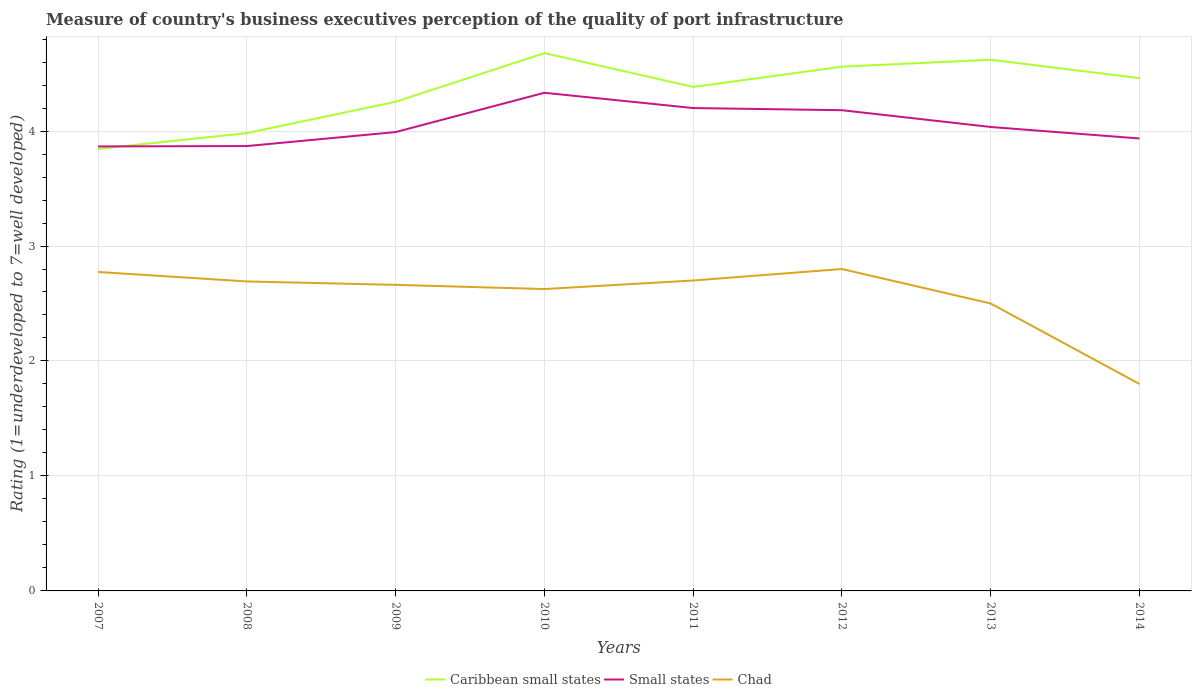How many different coloured lines are there?
Your response must be concise. 3. Does the line corresponding to Small states intersect with the line corresponding to Chad?
Offer a terse response. No. Across all years, what is the maximum ratings of the quality of port infrastructure in Chad?
Keep it short and to the point. 1.8. In which year was the ratings of the quality of port infrastructure in Caribbean small states maximum?
Your answer should be compact. 2007. What is the total ratings of the quality of port infrastructure in Small states in the graph?
Your answer should be compact. 0.13. What is the difference between the highest and the second highest ratings of the quality of port infrastructure in Caribbean small states?
Provide a short and direct response. 0.83. Is the ratings of the quality of port infrastructure in Chad strictly greater than the ratings of the quality of port infrastructure in Small states over the years?
Ensure brevity in your answer.  Yes. What is the difference between two consecutive major ticks on the Y-axis?
Your answer should be compact. 1. Does the graph contain any zero values?
Ensure brevity in your answer.  No. How are the legend labels stacked?
Keep it short and to the point. Horizontal. What is the title of the graph?
Your answer should be compact. Measure of country's business executives perception of the quality of port infrastructure. What is the label or title of the X-axis?
Offer a very short reply. Years. What is the label or title of the Y-axis?
Your answer should be very brief. Rating (1=underdeveloped to 7=well developed). What is the Rating (1=underdeveloped to 7=well developed) of Caribbean small states in 2007?
Your answer should be very brief. 3.85. What is the Rating (1=underdeveloped to 7=well developed) in Small states in 2007?
Keep it short and to the point. 3.87. What is the Rating (1=underdeveloped to 7=well developed) of Chad in 2007?
Your response must be concise. 2.77. What is the Rating (1=underdeveloped to 7=well developed) in Caribbean small states in 2008?
Offer a very short reply. 3.98. What is the Rating (1=underdeveloped to 7=well developed) in Small states in 2008?
Your answer should be compact. 3.87. What is the Rating (1=underdeveloped to 7=well developed) of Chad in 2008?
Offer a terse response. 2.69. What is the Rating (1=underdeveloped to 7=well developed) in Caribbean small states in 2009?
Your answer should be compact. 4.26. What is the Rating (1=underdeveloped to 7=well developed) in Small states in 2009?
Offer a terse response. 3.99. What is the Rating (1=underdeveloped to 7=well developed) in Chad in 2009?
Your answer should be compact. 2.66. What is the Rating (1=underdeveloped to 7=well developed) in Caribbean small states in 2010?
Make the answer very short. 4.68. What is the Rating (1=underdeveloped to 7=well developed) of Small states in 2010?
Offer a very short reply. 4.33. What is the Rating (1=underdeveloped to 7=well developed) in Chad in 2010?
Offer a terse response. 2.63. What is the Rating (1=underdeveloped to 7=well developed) of Caribbean small states in 2011?
Offer a very short reply. 4.38. What is the Rating (1=underdeveloped to 7=well developed) in Small states in 2011?
Provide a succinct answer. 4.2. What is the Rating (1=underdeveloped to 7=well developed) of Chad in 2011?
Make the answer very short. 2.7. What is the Rating (1=underdeveloped to 7=well developed) in Caribbean small states in 2012?
Make the answer very short. 4.56. What is the Rating (1=underdeveloped to 7=well developed) of Small states in 2012?
Provide a succinct answer. 4.18. What is the Rating (1=underdeveloped to 7=well developed) in Chad in 2012?
Your response must be concise. 2.8. What is the Rating (1=underdeveloped to 7=well developed) in Caribbean small states in 2013?
Your response must be concise. 4.62. What is the Rating (1=underdeveloped to 7=well developed) in Small states in 2013?
Give a very brief answer. 4.04. What is the Rating (1=underdeveloped to 7=well developed) of Caribbean small states in 2014?
Your answer should be very brief. 4.46. What is the Rating (1=underdeveloped to 7=well developed) in Small states in 2014?
Your response must be concise. 3.94. Across all years, what is the maximum Rating (1=underdeveloped to 7=well developed) of Caribbean small states?
Offer a terse response. 4.68. Across all years, what is the maximum Rating (1=underdeveloped to 7=well developed) of Small states?
Give a very brief answer. 4.33. Across all years, what is the minimum Rating (1=underdeveloped to 7=well developed) in Caribbean small states?
Ensure brevity in your answer.  3.85. Across all years, what is the minimum Rating (1=underdeveloped to 7=well developed) of Small states?
Your response must be concise. 3.87. Across all years, what is the minimum Rating (1=underdeveloped to 7=well developed) of Chad?
Your response must be concise. 1.8. What is the total Rating (1=underdeveloped to 7=well developed) in Caribbean small states in the graph?
Provide a succinct answer. 34.78. What is the total Rating (1=underdeveloped to 7=well developed) in Small states in the graph?
Give a very brief answer. 32.41. What is the total Rating (1=underdeveloped to 7=well developed) of Chad in the graph?
Keep it short and to the point. 20.55. What is the difference between the Rating (1=underdeveloped to 7=well developed) in Caribbean small states in 2007 and that in 2008?
Provide a succinct answer. -0.14. What is the difference between the Rating (1=underdeveloped to 7=well developed) of Small states in 2007 and that in 2008?
Your answer should be very brief. -0. What is the difference between the Rating (1=underdeveloped to 7=well developed) in Chad in 2007 and that in 2008?
Provide a succinct answer. 0.08. What is the difference between the Rating (1=underdeveloped to 7=well developed) in Caribbean small states in 2007 and that in 2009?
Make the answer very short. -0.41. What is the difference between the Rating (1=underdeveloped to 7=well developed) of Small states in 2007 and that in 2009?
Provide a short and direct response. -0.12. What is the difference between the Rating (1=underdeveloped to 7=well developed) of Chad in 2007 and that in 2009?
Offer a terse response. 0.11. What is the difference between the Rating (1=underdeveloped to 7=well developed) in Caribbean small states in 2007 and that in 2010?
Keep it short and to the point. -0.83. What is the difference between the Rating (1=underdeveloped to 7=well developed) of Small states in 2007 and that in 2010?
Your answer should be compact. -0.47. What is the difference between the Rating (1=underdeveloped to 7=well developed) in Chad in 2007 and that in 2010?
Ensure brevity in your answer.  0.15. What is the difference between the Rating (1=underdeveloped to 7=well developed) of Caribbean small states in 2007 and that in 2011?
Offer a very short reply. -0.54. What is the difference between the Rating (1=underdeveloped to 7=well developed) in Small states in 2007 and that in 2011?
Offer a terse response. -0.33. What is the difference between the Rating (1=underdeveloped to 7=well developed) in Chad in 2007 and that in 2011?
Your answer should be compact. 0.07. What is the difference between the Rating (1=underdeveloped to 7=well developed) of Caribbean small states in 2007 and that in 2012?
Give a very brief answer. -0.71. What is the difference between the Rating (1=underdeveloped to 7=well developed) of Small states in 2007 and that in 2012?
Offer a very short reply. -0.32. What is the difference between the Rating (1=underdeveloped to 7=well developed) in Chad in 2007 and that in 2012?
Give a very brief answer. -0.03. What is the difference between the Rating (1=underdeveloped to 7=well developed) of Caribbean small states in 2007 and that in 2013?
Your response must be concise. -0.77. What is the difference between the Rating (1=underdeveloped to 7=well developed) of Small states in 2007 and that in 2013?
Make the answer very short. -0.17. What is the difference between the Rating (1=underdeveloped to 7=well developed) of Chad in 2007 and that in 2013?
Make the answer very short. 0.27. What is the difference between the Rating (1=underdeveloped to 7=well developed) in Caribbean small states in 2007 and that in 2014?
Your answer should be very brief. -0.61. What is the difference between the Rating (1=underdeveloped to 7=well developed) of Small states in 2007 and that in 2014?
Make the answer very short. -0.07. What is the difference between the Rating (1=underdeveloped to 7=well developed) in Chad in 2007 and that in 2014?
Give a very brief answer. 0.97. What is the difference between the Rating (1=underdeveloped to 7=well developed) in Caribbean small states in 2008 and that in 2009?
Keep it short and to the point. -0.27. What is the difference between the Rating (1=underdeveloped to 7=well developed) in Small states in 2008 and that in 2009?
Your response must be concise. -0.12. What is the difference between the Rating (1=underdeveloped to 7=well developed) in Chad in 2008 and that in 2009?
Make the answer very short. 0.03. What is the difference between the Rating (1=underdeveloped to 7=well developed) in Caribbean small states in 2008 and that in 2010?
Keep it short and to the point. -0.7. What is the difference between the Rating (1=underdeveloped to 7=well developed) of Small states in 2008 and that in 2010?
Offer a terse response. -0.46. What is the difference between the Rating (1=underdeveloped to 7=well developed) in Chad in 2008 and that in 2010?
Provide a succinct answer. 0.07. What is the difference between the Rating (1=underdeveloped to 7=well developed) in Caribbean small states in 2008 and that in 2011?
Your answer should be very brief. -0.4. What is the difference between the Rating (1=underdeveloped to 7=well developed) in Small states in 2008 and that in 2011?
Your response must be concise. -0.33. What is the difference between the Rating (1=underdeveloped to 7=well developed) of Chad in 2008 and that in 2011?
Offer a very short reply. -0.01. What is the difference between the Rating (1=underdeveloped to 7=well developed) of Caribbean small states in 2008 and that in 2012?
Keep it short and to the point. -0.58. What is the difference between the Rating (1=underdeveloped to 7=well developed) in Small states in 2008 and that in 2012?
Offer a terse response. -0.31. What is the difference between the Rating (1=underdeveloped to 7=well developed) of Chad in 2008 and that in 2012?
Offer a very short reply. -0.11. What is the difference between the Rating (1=underdeveloped to 7=well developed) in Caribbean small states in 2008 and that in 2013?
Your answer should be compact. -0.64. What is the difference between the Rating (1=underdeveloped to 7=well developed) of Small states in 2008 and that in 2013?
Keep it short and to the point. -0.17. What is the difference between the Rating (1=underdeveloped to 7=well developed) of Chad in 2008 and that in 2013?
Ensure brevity in your answer.  0.19. What is the difference between the Rating (1=underdeveloped to 7=well developed) in Caribbean small states in 2008 and that in 2014?
Make the answer very short. -0.48. What is the difference between the Rating (1=underdeveloped to 7=well developed) of Small states in 2008 and that in 2014?
Keep it short and to the point. -0.07. What is the difference between the Rating (1=underdeveloped to 7=well developed) of Chad in 2008 and that in 2014?
Your response must be concise. 0.89. What is the difference between the Rating (1=underdeveloped to 7=well developed) in Caribbean small states in 2009 and that in 2010?
Offer a very short reply. -0.42. What is the difference between the Rating (1=underdeveloped to 7=well developed) in Small states in 2009 and that in 2010?
Make the answer very short. -0.34. What is the difference between the Rating (1=underdeveloped to 7=well developed) of Chad in 2009 and that in 2010?
Keep it short and to the point. 0.04. What is the difference between the Rating (1=underdeveloped to 7=well developed) in Caribbean small states in 2009 and that in 2011?
Keep it short and to the point. -0.13. What is the difference between the Rating (1=underdeveloped to 7=well developed) in Small states in 2009 and that in 2011?
Make the answer very short. -0.21. What is the difference between the Rating (1=underdeveloped to 7=well developed) in Chad in 2009 and that in 2011?
Keep it short and to the point. -0.04. What is the difference between the Rating (1=underdeveloped to 7=well developed) in Caribbean small states in 2009 and that in 2012?
Your response must be concise. -0.3. What is the difference between the Rating (1=underdeveloped to 7=well developed) of Small states in 2009 and that in 2012?
Your answer should be very brief. -0.19. What is the difference between the Rating (1=underdeveloped to 7=well developed) of Chad in 2009 and that in 2012?
Keep it short and to the point. -0.14. What is the difference between the Rating (1=underdeveloped to 7=well developed) in Caribbean small states in 2009 and that in 2013?
Provide a short and direct response. -0.36. What is the difference between the Rating (1=underdeveloped to 7=well developed) of Small states in 2009 and that in 2013?
Keep it short and to the point. -0.04. What is the difference between the Rating (1=underdeveloped to 7=well developed) in Chad in 2009 and that in 2013?
Your response must be concise. 0.16. What is the difference between the Rating (1=underdeveloped to 7=well developed) of Caribbean small states in 2009 and that in 2014?
Your answer should be compact. -0.2. What is the difference between the Rating (1=underdeveloped to 7=well developed) of Small states in 2009 and that in 2014?
Make the answer very short. 0.06. What is the difference between the Rating (1=underdeveloped to 7=well developed) in Chad in 2009 and that in 2014?
Your answer should be compact. 0.86. What is the difference between the Rating (1=underdeveloped to 7=well developed) in Caribbean small states in 2010 and that in 2011?
Your answer should be very brief. 0.29. What is the difference between the Rating (1=underdeveloped to 7=well developed) of Small states in 2010 and that in 2011?
Offer a terse response. 0.13. What is the difference between the Rating (1=underdeveloped to 7=well developed) of Chad in 2010 and that in 2011?
Your answer should be compact. -0.07. What is the difference between the Rating (1=underdeveloped to 7=well developed) of Caribbean small states in 2010 and that in 2012?
Your response must be concise. 0.12. What is the difference between the Rating (1=underdeveloped to 7=well developed) of Small states in 2010 and that in 2012?
Keep it short and to the point. 0.15. What is the difference between the Rating (1=underdeveloped to 7=well developed) of Chad in 2010 and that in 2012?
Your answer should be compact. -0.17. What is the difference between the Rating (1=underdeveloped to 7=well developed) of Caribbean small states in 2010 and that in 2013?
Your answer should be compact. 0.06. What is the difference between the Rating (1=underdeveloped to 7=well developed) of Small states in 2010 and that in 2013?
Keep it short and to the point. 0.3. What is the difference between the Rating (1=underdeveloped to 7=well developed) of Chad in 2010 and that in 2013?
Provide a short and direct response. 0.13. What is the difference between the Rating (1=underdeveloped to 7=well developed) of Caribbean small states in 2010 and that in 2014?
Offer a terse response. 0.22. What is the difference between the Rating (1=underdeveloped to 7=well developed) in Small states in 2010 and that in 2014?
Make the answer very short. 0.4. What is the difference between the Rating (1=underdeveloped to 7=well developed) in Chad in 2010 and that in 2014?
Offer a very short reply. 0.83. What is the difference between the Rating (1=underdeveloped to 7=well developed) in Caribbean small states in 2011 and that in 2012?
Make the answer very short. -0.18. What is the difference between the Rating (1=underdeveloped to 7=well developed) in Small states in 2011 and that in 2012?
Your answer should be very brief. 0.02. What is the difference between the Rating (1=underdeveloped to 7=well developed) in Caribbean small states in 2011 and that in 2013?
Give a very brief answer. -0.24. What is the difference between the Rating (1=underdeveloped to 7=well developed) of Small states in 2011 and that in 2013?
Make the answer very short. 0.16. What is the difference between the Rating (1=underdeveloped to 7=well developed) in Caribbean small states in 2011 and that in 2014?
Give a very brief answer. -0.08. What is the difference between the Rating (1=underdeveloped to 7=well developed) in Small states in 2011 and that in 2014?
Offer a very short reply. 0.26. What is the difference between the Rating (1=underdeveloped to 7=well developed) of Chad in 2011 and that in 2014?
Give a very brief answer. 0.9. What is the difference between the Rating (1=underdeveloped to 7=well developed) in Caribbean small states in 2012 and that in 2013?
Keep it short and to the point. -0.06. What is the difference between the Rating (1=underdeveloped to 7=well developed) of Small states in 2012 and that in 2013?
Provide a short and direct response. 0.15. What is the difference between the Rating (1=underdeveloped to 7=well developed) in Small states in 2012 and that in 2014?
Provide a short and direct response. 0.25. What is the difference between the Rating (1=underdeveloped to 7=well developed) in Chad in 2012 and that in 2014?
Ensure brevity in your answer.  1. What is the difference between the Rating (1=underdeveloped to 7=well developed) in Caribbean small states in 2013 and that in 2014?
Your response must be concise. 0.16. What is the difference between the Rating (1=underdeveloped to 7=well developed) in Caribbean small states in 2007 and the Rating (1=underdeveloped to 7=well developed) in Small states in 2008?
Provide a short and direct response. -0.02. What is the difference between the Rating (1=underdeveloped to 7=well developed) in Caribbean small states in 2007 and the Rating (1=underdeveloped to 7=well developed) in Chad in 2008?
Provide a succinct answer. 1.15. What is the difference between the Rating (1=underdeveloped to 7=well developed) of Small states in 2007 and the Rating (1=underdeveloped to 7=well developed) of Chad in 2008?
Make the answer very short. 1.17. What is the difference between the Rating (1=underdeveloped to 7=well developed) of Caribbean small states in 2007 and the Rating (1=underdeveloped to 7=well developed) of Small states in 2009?
Your response must be concise. -0.15. What is the difference between the Rating (1=underdeveloped to 7=well developed) in Caribbean small states in 2007 and the Rating (1=underdeveloped to 7=well developed) in Chad in 2009?
Your answer should be very brief. 1.18. What is the difference between the Rating (1=underdeveloped to 7=well developed) in Small states in 2007 and the Rating (1=underdeveloped to 7=well developed) in Chad in 2009?
Ensure brevity in your answer.  1.2. What is the difference between the Rating (1=underdeveloped to 7=well developed) of Caribbean small states in 2007 and the Rating (1=underdeveloped to 7=well developed) of Small states in 2010?
Provide a succinct answer. -0.49. What is the difference between the Rating (1=underdeveloped to 7=well developed) in Caribbean small states in 2007 and the Rating (1=underdeveloped to 7=well developed) in Chad in 2010?
Your answer should be very brief. 1.22. What is the difference between the Rating (1=underdeveloped to 7=well developed) in Small states in 2007 and the Rating (1=underdeveloped to 7=well developed) in Chad in 2010?
Your response must be concise. 1.24. What is the difference between the Rating (1=underdeveloped to 7=well developed) in Caribbean small states in 2007 and the Rating (1=underdeveloped to 7=well developed) in Small states in 2011?
Make the answer very short. -0.35. What is the difference between the Rating (1=underdeveloped to 7=well developed) in Caribbean small states in 2007 and the Rating (1=underdeveloped to 7=well developed) in Chad in 2011?
Provide a succinct answer. 1.15. What is the difference between the Rating (1=underdeveloped to 7=well developed) of Small states in 2007 and the Rating (1=underdeveloped to 7=well developed) of Chad in 2011?
Offer a very short reply. 1.17. What is the difference between the Rating (1=underdeveloped to 7=well developed) of Caribbean small states in 2007 and the Rating (1=underdeveloped to 7=well developed) of Small states in 2012?
Provide a short and direct response. -0.34. What is the difference between the Rating (1=underdeveloped to 7=well developed) in Caribbean small states in 2007 and the Rating (1=underdeveloped to 7=well developed) in Chad in 2012?
Make the answer very short. 1.05. What is the difference between the Rating (1=underdeveloped to 7=well developed) in Small states in 2007 and the Rating (1=underdeveloped to 7=well developed) in Chad in 2012?
Ensure brevity in your answer.  1.07. What is the difference between the Rating (1=underdeveloped to 7=well developed) in Caribbean small states in 2007 and the Rating (1=underdeveloped to 7=well developed) in Small states in 2013?
Offer a terse response. -0.19. What is the difference between the Rating (1=underdeveloped to 7=well developed) of Caribbean small states in 2007 and the Rating (1=underdeveloped to 7=well developed) of Chad in 2013?
Your answer should be compact. 1.35. What is the difference between the Rating (1=underdeveloped to 7=well developed) of Small states in 2007 and the Rating (1=underdeveloped to 7=well developed) of Chad in 2013?
Offer a very short reply. 1.37. What is the difference between the Rating (1=underdeveloped to 7=well developed) in Caribbean small states in 2007 and the Rating (1=underdeveloped to 7=well developed) in Small states in 2014?
Offer a terse response. -0.09. What is the difference between the Rating (1=underdeveloped to 7=well developed) in Caribbean small states in 2007 and the Rating (1=underdeveloped to 7=well developed) in Chad in 2014?
Offer a very short reply. 2.05. What is the difference between the Rating (1=underdeveloped to 7=well developed) of Small states in 2007 and the Rating (1=underdeveloped to 7=well developed) of Chad in 2014?
Offer a terse response. 2.07. What is the difference between the Rating (1=underdeveloped to 7=well developed) of Caribbean small states in 2008 and the Rating (1=underdeveloped to 7=well developed) of Small states in 2009?
Provide a short and direct response. -0.01. What is the difference between the Rating (1=underdeveloped to 7=well developed) of Caribbean small states in 2008 and the Rating (1=underdeveloped to 7=well developed) of Chad in 2009?
Your answer should be very brief. 1.32. What is the difference between the Rating (1=underdeveloped to 7=well developed) of Small states in 2008 and the Rating (1=underdeveloped to 7=well developed) of Chad in 2009?
Your answer should be very brief. 1.21. What is the difference between the Rating (1=underdeveloped to 7=well developed) of Caribbean small states in 2008 and the Rating (1=underdeveloped to 7=well developed) of Small states in 2010?
Make the answer very short. -0.35. What is the difference between the Rating (1=underdeveloped to 7=well developed) of Caribbean small states in 2008 and the Rating (1=underdeveloped to 7=well developed) of Chad in 2010?
Your response must be concise. 1.36. What is the difference between the Rating (1=underdeveloped to 7=well developed) of Small states in 2008 and the Rating (1=underdeveloped to 7=well developed) of Chad in 2010?
Your answer should be very brief. 1.24. What is the difference between the Rating (1=underdeveloped to 7=well developed) of Caribbean small states in 2008 and the Rating (1=underdeveloped to 7=well developed) of Small states in 2011?
Keep it short and to the point. -0.22. What is the difference between the Rating (1=underdeveloped to 7=well developed) of Caribbean small states in 2008 and the Rating (1=underdeveloped to 7=well developed) of Chad in 2011?
Keep it short and to the point. 1.28. What is the difference between the Rating (1=underdeveloped to 7=well developed) of Small states in 2008 and the Rating (1=underdeveloped to 7=well developed) of Chad in 2011?
Make the answer very short. 1.17. What is the difference between the Rating (1=underdeveloped to 7=well developed) in Caribbean small states in 2008 and the Rating (1=underdeveloped to 7=well developed) in Small states in 2012?
Offer a very short reply. -0.2. What is the difference between the Rating (1=underdeveloped to 7=well developed) of Caribbean small states in 2008 and the Rating (1=underdeveloped to 7=well developed) of Chad in 2012?
Keep it short and to the point. 1.18. What is the difference between the Rating (1=underdeveloped to 7=well developed) of Small states in 2008 and the Rating (1=underdeveloped to 7=well developed) of Chad in 2012?
Keep it short and to the point. 1.07. What is the difference between the Rating (1=underdeveloped to 7=well developed) of Caribbean small states in 2008 and the Rating (1=underdeveloped to 7=well developed) of Small states in 2013?
Your answer should be very brief. -0.05. What is the difference between the Rating (1=underdeveloped to 7=well developed) of Caribbean small states in 2008 and the Rating (1=underdeveloped to 7=well developed) of Chad in 2013?
Offer a very short reply. 1.48. What is the difference between the Rating (1=underdeveloped to 7=well developed) in Small states in 2008 and the Rating (1=underdeveloped to 7=well developed) in Chad in 2013?
Your answer should be very brief. 1.37. What is the difference between the Rating (1=underdeveloped to 7=well developed) of Caribbean small states in 2008 and the Rating (1=underdeveloped to 7=well developed) of Small states in 2014?
Your answer should be very brief. 0.05. What is the difference between the Rating (1=underdeveloped to 7=well developed) in Caribbean small states in 2008 and the Rating (1=underdeveloped to 7=well developed) in Chad in 2014?
Your response must be concise. 2.18. What is the difference between the Rating (1=underdeveloped to 7=well developed) in Small states in 2008 and the Rating (1=underdeveloped to 7=well developed) in Chad in 2014?
Offer a very short reply. 2.07. What is the difference between the Rating (1=underdeveloped to 7=well developed) in Caribbean small states in 2009 and the Rating (1=underdeveloped to 7=well developed) in Small states in 2010?
Offer a very short reply. -0.08. What is the difference between the Rating (1=underdeveloped to 7=well developed) of Caribbean small states in 2009 and the Rating (1=underdeveloped to 7=well developed) of Chad in 2010?
Your answer should be compact. 1.63. What is the difference between the Rating (1=underdeveloped to 7=well developed) of Small states in 2009 and the Rating (1=underdeveloped to 7=well developed) of Chad in 2010?
Provide a succinct answer. 1.37. What is the difference between the Rating (1=underdeveloped to 7=well developed) of Caribbean small states in 2009 and the Rating (1=underdeveloped to 7=well developed) of Small states in 2011?
Keep it short and to the point. 0.06. What is the difference between the Rating (1=underdeveloped to 7=well developed) of Caribbean small states in 2009 and the Rating (1=underdeveloped to 7=well developed) of Chad in 2011?
Give a very brief answer. 1.56. What is the difference between the Rating (1=underdeveloped to 7=well developed) of Small states in 2009 and the Rating (1=underdeveloped to 7=well developed) of Chad in 2011?
Your response must be concise. 1.29. What is the difference between the Rating (1=underdeveloped to 7=well developed) in Caribbean small states in 2009 and the Rating (1=underdeveloped to 7=well developed) in Small states in 2012?
Keep it short and to the point. 0.07. What is the difference between the Rating (1=underdeveloped to 7=well developed) of Caribbean small states in 2009 and the Rating (1=underdeveloped to 7=well developed) of Chad in 2012?
Your answer should be very brief. 1.46. What is the difference between the Rating (1=underdeveloped to 7=well developed) in Small states in 2009 and the Rating (1=underdeveloped to 7=well developed) in Chad in 2012?
Make the answer very short. 1.19. What is the difference between the Rating (1=underdeveloped to 7=well developed) of Caribbean small states in 2009 and the Rating (1=underdeveloped to 7=well developed) of Small states in 2013?
Keep it short and to the point. 0.22. What is the difference between the Rating (1=underdeveloped to 7=well developed) in Caribbean small states in 2009 and the Rating (1=underdeveloped to 7=well developed) in Chad in 2013?
Your answer should be very brief. 1.76. What is the difference between the Rating (1=underdeveloped to 7=well developed) in Small states in 2009 and the Rating (1=underdeveloped to 7=well developed) in Chad in 2013?
Ensure brevity in your answer.  1.49. What is the difference between the Rating (1=underdeveloped to 7=well developed) of Caribbean small states in 2009 and the Rating (1=underdeveloped to 7=well developed) of Small states in 2014?
Keep it short and to the point. 0.32. What is the difference between the Rating (1=underdeveloped to 7=well developed) of Caribbean small states in 2009 and the Rating (1=underdeveloped to 7=well developed) of Chad in 2014?
Ensure brevity in your answer.  2.46. What is the difference between the Rating (1=underdeveloped to 7=well developed) of Small states in 2009 and the Rating (1=underdeveloped to 7=well developed) of Chad in 2014?
Your response must be concise. 2.19. What is the difference between the Rating (1=underdeveloped to 7=well developed) in Caribbean small states in 2010 and the Rating (1=underdeveloped to 7=well developed) in Small states in 2011?
Make the answer very short. 0.48. What is the difference between the Rating (1=underdeveloped to 7=well developed) in Caribbean small states in 2010 and the Rating (1=underdeveloped to 7=well developed) in Chad in 2011?
Make the answer very short. 1.98. What is the difference between the Rating (1=underdeveloped to 7=well developed) of Small states in 2010 and the Rating (1=underdeveloped to 7=well developed) of Chad in 2011?
Your answer should be very brief. 1.63. What is the difference between the Rating (1=underdeveloped to 7=well developed) of Caribbean small states in 2010 and the Rating (1=underdeveloped to 7=well developed) of Small states in 2012?
Your answer should be compact. 0.5. What is the difference between the Rating (1=underdeveloped to 7=well developed) of Caribbean small states in 2010 and the Rating (1=underdeveloped to 7=well developed) of Chad in 2012?
Your answer should be very brief. 1.88. What is the difference between the Rating (1=underdeveloped to 7=well developed) of Small states in 2010 and the Rating (1=underdeveloped to 7=well developed) of Chad in 2012?
Your answer should be compact. 1.53. What is the difference between the Rating (1=underdeveloped to 7=well developed) in Caribbean small states in 2010 and the Rating (1=underdeveloped to 7=well developed) in Small states in 2013?
Provide a short and direct response. 0.64. What is the difference between the Rating (1=underdeveloped to 7=well developed) of Caribbean small states in 2010 and the Rating (1=underdeveloped to 7=well developed) of Chad in 2013?
Offer a terse response. 2.18. What is the difference between the Rating (1=underdeveloped to 7=well developed) of Small states in 2010 and the Rating (1=underdeveloped to 7=well developed) of Chad in 2013?
Your response must be concise. 1.83. What is the difference between the Rating (1=underdeveloped to 7=well developed) in Caribbean small states in 2010 and the Rating (1=underdeveloped to 7=well developed) in Small states in 2014?
Ensure brevity in your answer.  0.74. What is the difference between the Rating (1=underdeveloped to 7=well developed) in Caribbean small states in 2010 and the Rating (1=underdeveloped to 7=well developed) in Chad in 2014?
Give a very brief answer. 2.88. What is the difference between the Rating (1=underdeveloped to 7=well developed) of Small states in 2010 and the Rating (1=underdeveloped to 7=well developed) of Chad in 2014?
Offer a very short reply. 2.53. What is the difference between the Rating (1=underdeveloped to 7=well developed) of Caribbean small states in 2011 and the Rating (1=underdeveloped to 7=well developed) of Small states in 2012?
Ensure brevity in your answer.  0.2. What is the difference between the Rating (1=underdeveloped to 7=well developed) in Caribbean small states in 2011 and the Rating (1=underdeveloped to 7=well developed) in Chad in 2012?
Offer a terse response. 1.58. What is the difference between the Rating (1=underdeveloped to 7=well developed) in Small states in 2011 and the Rating (1=underdeveloped to 7=well developed) in Chad in 2012?
Your response must be concise. 1.4. What is the difference between the Rating (1=underdeveloped to 7=well developed) in Caribbean small states in 2011 and the Rating (1=underdeveloped to 7=well developed) in Small states in 2013?
Your response must be concise. 0.35. What is the difference between the Rating (1=underdeveloped to 7=well developed) of Caribbean small states in 2011 and the Rating (1=underdeveloped to 7=well developed) of Chad in 2013?
Keep it short and to the point. 1.88. What is the difference between the Rating (1=underdeveloped to 7=well developed) in Caribbean small states in 2011 and the Rating (1=underdeveloped to 7=well developed) in Small states in 2014?
Your answer should be compact. 0.45. What is the difference between the Rating (1=underdeveloped to 7=well developed) of Caribbean small states in 2011 and the Rating (1=underdeveloped to 7=well developed) of Chad in 2014?
Provide a succinct answer. 2.58. What is the difference between the Rating (1=underdeveloped to 7=well developed) of Caribbean small states in 2012 and the Rating (1=underdeveloped to 7=well developed) of Small states in 2013?
Provide a short and direct response. 0.52. What is the difference between the Rating (1=underdeveloped to 7=well developed) of Caribbean small states in 2012 and the Rating (1=underdeveloped to 7=well developed) of Chad in 2013?
Keep it short and to the point. 2.06. What is the difference between the Rating (1=underdeveloped to 7=well developed) of Small states in 2012 and the Rating (1=underdeveloped to 7=well developed) of Chad in 2013?
Keep it short and to the point. 1.68. What is the difference between the Rating (1=underdeveloped to 7=well developed) in Caribbean small states in 2012 and the Rating (1=underdeveloped to 7=well developed) in Small states in 2014?
Give a very brief answer. 0.62. What is the difference between the Rating (1=underdeveloped to 7=well developed) in Caribbean small states in 2012 and the Rating (1=underdeveloped to 7=well developed) in Chad in 2014?
Your answer should be very brief. 2.76. What is the difference between the Rating (1=underdeveloped to 7=well developed) of Small states in 2012 and the Rating (1=underdeveloped to 7=well developed) of Chad in 2014?
Your answer should be very brief. 2.38. What is the difference between the Rating (1=underdeveloped to 7=well developed) in Caribbean small states in 2013 and the Rating (1=underdeveloped to 7=well developed) in Small states in 2014?
Offer a very short reply. 0.68. What is the difference between the Rating (1=underdeveloped to 7=well developed) in Caribbean small states in 2013 and the Rating (1=underdeveloped to 7=well developed) in Chad in 2014?
Your answer should be very brief. 2.82. What is the difference between the Rating (1=underdeveloped to 7=well developed) in Small states in 2013 and the Rating (1=underdeveloped to 7=well developed) in Chad in 2014?
Offer a very short reply. 2.24. What is the average Rating (1=underdeveloped to 7=well developed) in Caribbean small states per year?
Make the answer very short. 4.35. What is the average Rating (1=underdeveloped to 7=well developed) in Small states per year?
Provide a short and direct response. 4.05. What is the average Rating (1=underdeveloped to 7=well developed) in Chad per year?
Your answer should be compact. 2.57. In the year 2007, what is the difference between the Rating (1=underdeveloped to 7=well developed) of Caribbean small states and Rating (1=underdeveloped to 7=well developed) of Small states?
Make the answer very short. -0.02. In the year 2007, what is the difference between the Rating (1=underdeveloped to 7=well developed) in Caribbean small states and Rating (1=underdeveloped to 7=well developed) in Chad?
Offer a terse response. 1.07. In the year 2007, what is the difference between the Rating (1=underdeveloped to 7=well developed) of Small states and Rating (1=underdeveloped to 7=well developed) of Chad?
Offer a very short reply. 1.09. In the year 2008, what is the difference between the Rating (1=underdeveloped to 7=well developed) in Caribbean small states and Rating (1=underdeveloped to 7=well developed) in Small states?
Ensure brevity in your answer.  0.11. In the year 2008, what is the difference between the Rating (1=underdeveloped to 7=well developed) in Caribbean small states and Rating (1=underdeveloped to 7=well developed) in Chad?
Offer a very short reply. 1.29. In the year 2008, what is the difference between the Rating (1=underdeveloped to 7=well developed) of Small states and Rating (1=underdeveloped to 7=well developed) of Chad?
Ensure brevity in your answer.  1.18. In the year 2009, what is the difference between the Rating (1=underdeveloped to 7=well developed) of Caribbean small states and Rating (1=underdeveloped to 7=well developed) of Small states?
Your answer should be compact. 0.26. In the year 2009, what is the difference between the Rating (1=underdeveloped to 7=well developed) of Caribbean small states and Rating (1=underdeveloped to 7=well developed) of Chad?
Your response must be concise. 1.59. In the year 2009, what is the difference between the Rating (1=underdeveloped to 7=well developed) in Small states and Rating (1=underdeveloped to 7=well developed) in Chad?
Provide a succinct answer. 1.33. In the year 2010, what is the difference between the Rating (1=underdeveloped to 7=well developed) of Caribbean small states and Rating (1=underdeveloped to 7=well developed) of Small states?
Keep it short and to the point. 0.34. In the year 2010, what is the difference between the Rating (1=underdeveloped to 7=well developed) of Caribbean small states and Rating (1=underdeveloped to 7=well developed) of Chad?
Ensure brevity in your answer.  2.05. In the year 2010, what is the difference between the Rating (1=underdeveloped to 7=well developed) in Small states and Rating (1=underdeveloped to 7=well developed) in Chad?
Your answer should be very brief. 1.71. In the year 2011, what is the difference between the Rating (1=underdeveloped to 7=well developed) in Caribbean small states and Rating (1=underdeveloped to 7=well developed) in Small states?
Your answer should be very brief. 0.18. In the year 2011, what is the difference between the Rating (1=underdeveloped to 7=well developed) of Caribbean small states and Rating (1=underdeveloped to 7=well developed) of Chad?
Provide a succinct answer. 1.68. In the year 2012, what is the difference between the Rating (1=underdeveloped to 7=well developed) of Caribbean small states and Rating (1=underdeveloped to 7=well developed) of Small states?
Your answer should be very brief. 0.38. In the year 2012, what is the difference between the Rating (1=underdeveloped to 7=well developed) of Caribbean small states and Rating (1=underdeveloped to 7=well developed) of Chad?
Give a very brief answer. 1.76. In the year 2012, what is the difference between the Rating (1=underdeveloped to 7=well developed) of Small states and Rating (1=underdeveloped to 7=well developed) of Chad?
Provide a short and direct response. 1.38. In the year 2013, what is the difference between the Rating (1=underdeveloped to 7=well developed) of Caribbean small states and Rating (1=underdeveloped to 7=well developed) of Small states?
Offer a terse response. 0.58. In the year 2013, what is the difference between the Rating (1=underdeveloped to 7=well developed) of Caribbean small states and Rating (1=underdeveloped to 7=well developed) of Chad?
Offer a terse response. 2.12. In the year 2013, what is the difference between the Rating (1=underdeveloped to 7=well developed) in Small states and Rating (1=underdeveloped to 7=well developed) in Chad?
Your answer should be compact. 1.54. In the year 2014, what is the difference between the Rating (1=underdeveloped to 7=well developed) in Caribbean small states and Rating (1=underdeveloped to 7=well developed) in Small states?
Ensure brevity in your answer.  0.52. In the year 2014, what is the difference between the Rating (1=underdeveloped to 7=well developed) of Caribbean small states and Rating (1=underdeveloped to 7=well developed) of Chad?
Your answer should be compact. 2.66. In the year 2014, what is the difference between the Rating (1=underdeveloped to 7=well developed) of Small states and Rating (1=underdeveloped to 7=well developed) of Chad?
Provide a short and direct response. 2.14. What is the ratio of the Rating (1=underdeveloped to 7=well developed) in Caribbean small states in 2007 to that in 2008?
Offer a terse response. 0.97. What is the ratio of the Rating (1=underdeveloped to 7=well developed) in Small states in 2007 to that in 2008?
Ensure brevity in your answer.  1. What is the ratio of the Rating (1=underdeveloped to 7=well developed) in Chad in 2007 to that in 2008?
Ensure brevity in your answer.  1.03. What is the ratio of the Rating (1=underdeveloped to 7=well developed) in Caribbean small states in 2007 to that in 2009?
Keep it short and to the point. 0.9. What is the ratio of the Rating (1=underdeveloped to 7=well developed) in Small states in 2007 to that in 2009?
Ensure brevity in your answer.  0.97. What is the ratio of the Rating (1=underdeveloped to 7=well developed) in Chad in 2007 to that in 2009?
Provide a short and direct response. 1.04. What is the ratio of the Rating (1=underdeveloped to 7=well developed) of Caribbean small states in 2007 to that in 2010?
Make the answer very short. 0.82. What is the ratio of the Rating (1=underdeveloped to 7=well developed) of Small states in 2007 to that in 2010?
Ensure brevity in your answer.  0.89. What is the ratio of the Rating (1=underdeveloped to 7=well developed) of Chad in 2007 to that in 2010?
Give a very brief answer. 1.06. What is the ratio of the Rating (1=underdeveloped to 7=well developed) in Caribbean small states in 2007 to that in 2011?
Provide a short and direct response. 0.88. What is the ratio of the Rating (1=underdeveloped to 7=well developed) of Small states in 2007 to that in 2011?
Provide a short and direct response. 0.92. What is the ratio of the Rating (1=underdeveloped to 7=well developed) in Chad in 2007 to that in 2011?
Give a very brief answer. 1.03. What is the ratio of the Rating (1=underdeveloped to 7=well developed) of Caribbean small states in 2007 to that in 2012?
Keep it short and to the point. 0.84. What is the ratio of the Rating (1=underdeveloped to 7=well developed) in Small states in 2007 to that in 2012?
Give a very brief answer. 0.92. What is the ratio of the Rating (1=underdeveloped to 7=well developed) of Chad in 2007 to that in 2012?
Make the answer very short. 0.99. What is the ratio of the Rating (1=underdeveloped to 7=well developed) in Caribbean small states in 2007 to that in 2013?
Your answer should be compact. 0.83. What is the ratio of the Rating (1=underdeveloped to 7=well developed) of Small states in 2007 to that in 2013?
Make the answer very short. 0.96. What is the ratio of the Rating (1=underdeveloped to 7=well developed) of Chad in 2007 to that in 2013?
Make the answer very short. 1.11. What is the ratio of the Rating (1=underdeveloped to 7=well developed) of Caribbean small states in 2007 to that in 2014?
Provide a succinct answer. 0.86. What is the ratio of the Rating (1=underdeveloped to 7=well developed) in Small states in 2007 to that in 2014?
Keep it short and to the point. 0.98. What is the ratio of the Rating (1=underdeveloped to 7=well developed) in Chad in 2007 to that in 2014?
Offer a very short reply. 1.54. What is the ratio of the Rating (1=underdeveloped to 7=well developed) in Caribbean small states in 2008 to that in 2009?
Provide a succinct answer. 0.94. What is the ratio of the Rating (1=underdeveloped to 7=well developed) in Small states in 2008 to that in 2009?
Your answer should be compact. 0.97. What is the ratio of the Rating (1=underdeveloped to 7=well developed) of Chad in 2008 to that in 2009?
Offer a very short reply. 1.01. What is the ratio of the Rating (1=underdeveloped to 7=well developed) of Caribbean small states in 2008 to that in 2010?
Offer a very short reply. 0.85. What is the ratio of the Rating (1=underdeveloped to 7=well developed) of Small states in 2008 to that in 2010?
Your answer should be compact. 0.89. What is the ratio of the Rating (1=underdeveloped to 7=well developed) in Chad in 2008 to that in 2010?
Give a very brief answer. 1.03. What is the ratio of the Rating (1=underdeveloped to 7=well developed) of Caribbean small states in 2008 to that in 2011?
Ensure brevity in your answer.  0.91. What is the ratio of the Rating (1=underdeveloped to 7=well developed) of Small states in 2008 to that in 2011?
Make the answer very short. 0.92. What is the ratio of the Rating (1=underdeveloped to 7=well developed) of Caribbean small states in 2008 to that in 2012?
Offer a very short reply. 0.87. What is the ratio of the Rating (1=underdeveloped to 7=well developed) of Small states in 2008 to that in 2012?
Ensure brevity in your answer.  0.93. What is the ratio of the Rating (1=underdeveloped to 7=well developed) in Chad in 2008 to that in 2012?
Give a very brief answer. 0.96. What is the ratio of the Rating (1=underdeveloped to 7=well developed) of Caribbean small states in 2008 to that in 2013?
Your response must be concise. 0.86. What is the ratio of the Rating (1=underdeveloped to 7=well developed) in Small states in 2008 to that in 2013?
Your response must be concise. 0.96. What is the ratio of the Rating (1=underdeveloped to 7=well developed) in Chad in 2008 to that in 2013?
Your answer should be very brief. 1.08. What is the ratio of the Rating (1=underdeveloped to 7=well developed) in Caribbean small states in 2008 to that in 2014?
Provide a succinct answer. 0.89. What is the ratio of the Rating (1=underdeveloped to 7=well developed) in Small states in 2008 to that in 2014?
Your response must be concise. 0.98. What is the ratio of the Rating (1=underdeveloped to 7=well developed) in Chad in 2008 to that in 2014?
Your answer should be compact. 1.5. What is the ratio of the Rating (1=underdeveloped to 7=well developed) of Caribbean small states in 2009 to that in 2010?
Offer a very short reply. 0.91. What is the ratio of the Rating (1=underdeveloped to 7=well developed) of Small states in 2009 to that in 2010?
Offer a very short reply. 0.92. What is the ratio of the Rating (1=underdeveloped to 7=well developed) in Chad in 2009 to that in 2010?
Give a very brief answer. 1.01. What is the ratio of the Rating (1=underdeveloped to 7=well developed) of Caribbean small states in 2009 to that in 2011?
Provide a short and direct response. 0.97. What is the ratio of the Rating (1=underdeveloped to 7=well developed) of Small states in 2009 to that in 2011?
Provide a short and direct response. 0.95. What is the ratio of the Rating (1=underdeveloped to 7=well developed) in Caribbean small states in 2009 to that in 2012?
Offer a very short reply. 0.93. What is the ratio of the Rating (1=underdeveloped to 7=well developed) of Small states in 2009 to that in 2012?
Ensure brevity in your answer.  0.95. What is the ratio of the Rating (1=underdeveloped to 7=well developed) of Chad in 2009 to that in 2012?
Give a very brief answer. 0.95. What is the ratio of the Rating (1=underdeveloped to 7=well developed) of Caribbean small states in 2009 to that in 2013?
Offer a terse response. 0.92. What is the ratio of the Rating (1=underdeveloped to 7=well developed) of Small states in 2009 to that in 2013?
Make the answer very short. 0.99. What is the ratio of the Rating (1=underdeveloped to 7=well developed) in Chad in 2009 to that in 2013?
Your response must be concise. 1.06. What is the ratio of the Rating (1=underdeveloped to 7=well developed) in Caribbean small states in 2009 to that in 2014?
Ensure brevity in your answer.  0.95. What is the ratio of the Rating (1=underdeveloped to 7=well developed) of Small states in 2009 to that in 2014?
Your answer should be compact. 1.01. What is the ratio of the Rating (1=underdeveloped to 7=well developed) of Chad in 2009 to that in 2014?
Your answer should be very brief. 1.48. What is the ratio of the Rating (1=underdeveloped to 7=well developed) in Caribbean small states in 2010 to that in 2011?
Offer a terse response. 1.07. What is the ratio of the Rating (1=underdeveloped to 7=well developed) of Small states in 2010 to that in 2011?
Give a very brief answer. 1.03. What is the ratio of the Rating (1=underdeveloped to 7=well developed) of Chad in 2010 to that in 2011?
Make the answer very short. 0.97. What is the ratio of the Rating (1=underdeveloped to 7=well developed) in Caribbean small states in 2010 to that in 2012?
Your answer should be compact. 1.03. What is the ratio of the Rating (1=underdeveloped to 7=well developed) in Small states in 2010 to that in 2012?
Provide a short and direct response. 1.04. What is the ratio of the Rating (1=underdeveloped to 7=well developed) of Chad in 2010 to that in 2012?
Offer a terse response. 0.94. What is the ratio of the Rating (1=underdeveloped to 7=well developed) in Caribbean small states in 2010 to that in 2013?
Offer a terse response. 1.01. What is the ratio of the Rating (1=underdeveloped to 7=well developed) in Small states in 2010 to that in 2013?
Provide a succinct answer. 1.07. What is the ratio of the Rating (1=underdeveloped to 7=well developed) of Chad in 2010 to that in 2013?
Ensure brevity in your answer.  1.05. What is the ratio of the Rating (1=underdeveloped to 7=well developed) in Caribbean small states in 2010 to that in 2014?
Your response must be concise. 1.05. What is the ratio of the Rating (1=underdeveloped to 7=well developed) of Small states in 2010 to that in 2014?
Offer a terse response. 1.1. What is the ratio of the Rating (1=underdeveloped to 7=well developed) of Chad in 2010 to that in 2014?
Make the answer very short. 1.46. What is the ratio of the Rating (1=underdeveloped to 7=well developed) of Caribbean small states in 2011 to that in 2012?
Your answer should be compact. 0.96. What is the ratio of the Rating (1=underdeveloped to 7=well developed) in Small states in 2011 to that in 2012?
Offer a terse response. 1. What is the ratio of the Rating (1=underdeveloped to 7=well developed) in Caribbean small states in 2011 to that in 2013?
Ensure brevity in your answer.  0.95. What is the ratio of the Rating (1=underdeveloped to 7=well developed) of Small states in 2011 to that in 2013?
Provide a short and direct response. 1.04. What is the ratio of the Rating (1=underdeveloped to 7=well developed) of Chad in 2011 to that in 2013?
Give a very brief answer. 1.08. What is the ratio of the Rating (1=underdeveloped to 7=well developed) of Caribbean small states in 2011 to that in 2014?
Keep it short and to the point. 0.98. What is the ratio of the Rating (1=underdeveloped to 7=well developed) in Small states in 2011 to that in 2014?
Provide a succinct answer. 1.07. What is the ratio of the Rating (1=underdeveloped to 7=well developed) of Chad in 2011 to that in 2014?
Provide a short and direct response. 1.5. What is the ratio of the Rating (1=underdeveloped to 7=well developed) in Small states in 2012 to that in 2013?
Your answer should be very brief. 1.04. What is the ratio of the Rating (1=underdeveloped to 7=well developed) of Chad in 2012 to that in 2013?
Offer a very short reply. 1.12. What is the ratio of the Rating (1=underdeveloped to 7=well developed) of Caribbean small states in 2012 to that in 2014?
Provide a succinct answer. 1.02. What is the ratio of the Rating (1=underdeveloped to 7=well developed) in Chad in 2012 to that in 2014?
Provide a short and direct response. 1.56. What is the ratio of the Rating (1=underdeveloped to 7=well developed) of Caribbean small states in 2013 to that in 2014?
Offer a very short reply. 1.04. What is the ratio of the Rating (1=underdeveloped to 7=well developed) of Small states in 2013 to that in 2014?
Make the answer very short. 1.03. What is the ratio of the Rating (1=underdeveloped to 7=well developed) of Chad in 2013 to that in 2014?
Provide a succinct answer. 1.39. What is the difference between the highest and the second highest Rating (1=underdeveloped to 7=well developed) in Caribbean small states?
Provide a short and direct response. 0.06. What is the difference between the highest and the second highest Rating (1=underdeveloped to 7=well developed) in Small states?
Provide a short and direct response. 0.13. What is the difference between the highest and the second highest Rating (1=underdeveloped to 7=well developed) of Chad?
Provide a short and direct response. 0.03. What is the difference between the highest and the lowest Rating (1=underdeveloped to 7=well developed) in Caribbean small states?
Your answer should be very brief. 0.83. What is the difference between the highest and the lowest Rating (1=underdeveloped to 7=well developed) of Small states?
Ensure brevity in your answer.  0.47. What is the difference between the highest and the lowest Rating (1=underdeveloped to 7=well developed) in Chad?
Your answer should be very brief. 1. 